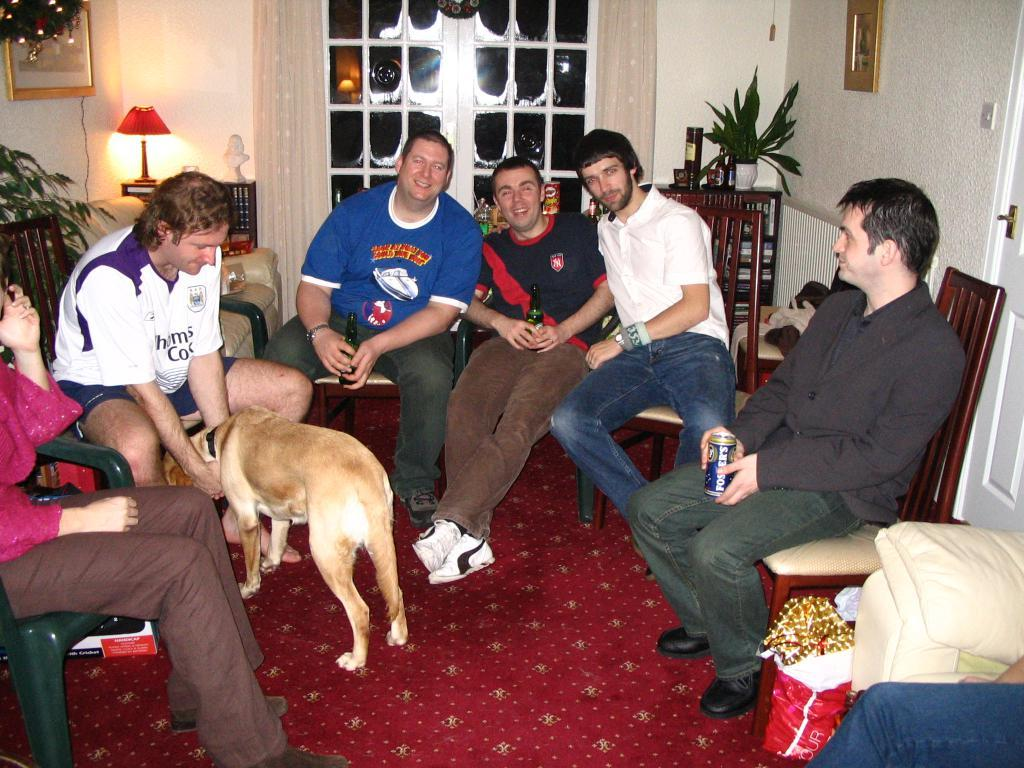What are the people in the image doing? There is a group of people sitting on chairs in the image. What type of animal can be seen in the image? There is a dog in the image. What objects are on the table in the image? There is a bottle, a tin, a cover, a lamp, a frame, and a flower pot on the table in the image. What architectural feature is present in the image? There is a door in the image. What type of van is parked outside the door in the image? There is no van present in the image; only a group of people, a dog, and various objects on a table are visible. Who is the father of the people sitting on chairs in the image? The provided facts do not give any information about the relationships between the people in the image, so it is impossible to determine who their father might be. 